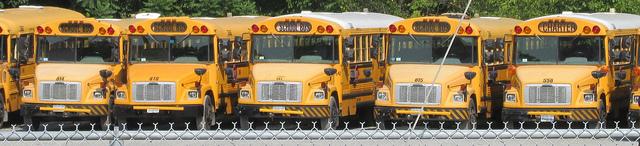How many buses are in this photo?
Give a very brief answer. 6. Are these buses off duty now?
Write a very short answer. Yes. What color are these buses?
Concise answer only. Yellow. 